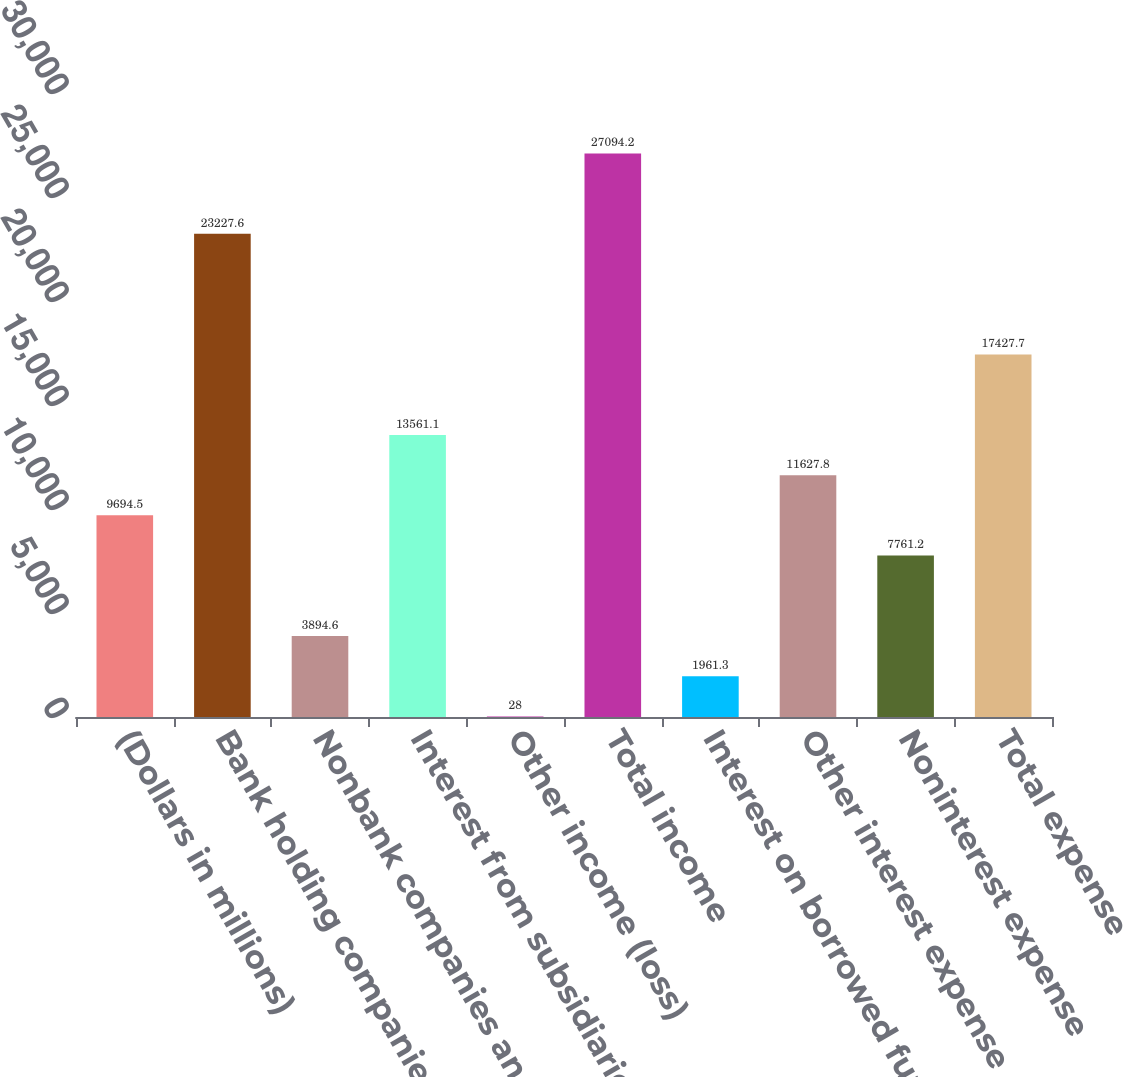Convert chart. <chart><loc_0><loc_0><loc_500><loc_500><bar_chart><fcel>(Dollars in millions)<fcel>Bank holding companies and<fcel>Nonbank companies and related<fcel>Interest from subsidiaries<fcel>Other income (loss)<fcel>Total income<fcel>Interest on borrowed funds<fcel>Other interest expense<fcel>Noninterest expense<fcel>Total expense<nl><fcel>9694.5<fcel>23227.6<fcel>3894.6<fcel>13561.1<fcel>28<fcel>27094.2<fcel>1961.3<fcel>11627.8<fcel>7761.2<fcel>17427.7<nl></chart> 